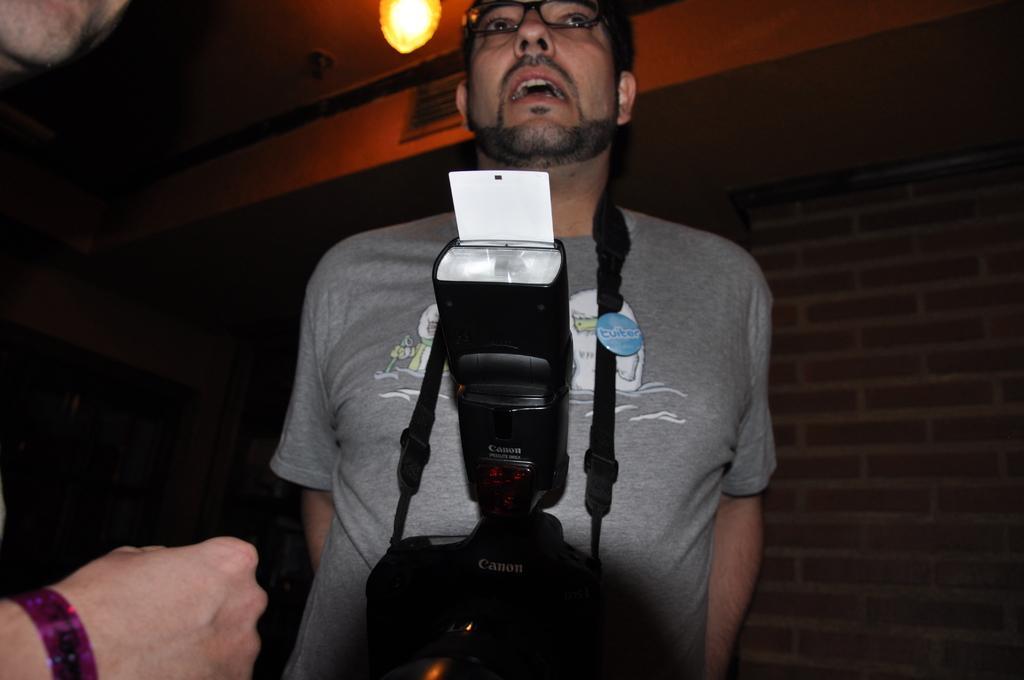In one or two sentences, can you explain what this image depicts? In this image there is a man in the middle. The man is wearing the camera with the belt. At the top there is the light. On the left side bottom there is a hand of the person. 